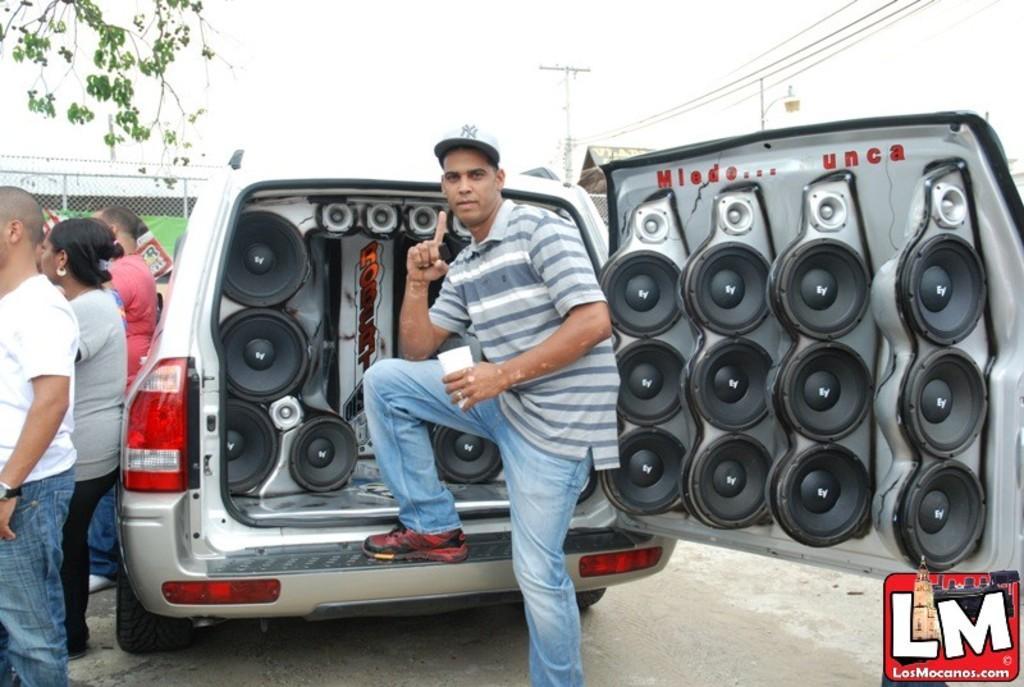How would you summarize this image in a sentence or two? In the background we can see the mesh, poles, transmission wires and objects. In this picture we can see a vehicle and objects. We can see a man is holding a glass and giving a pose. On the left side of the picture we can see the people. In the top left corner of the picture we can see green leaves and few branches. In the bottom right corner of the picture we can see watermark. 